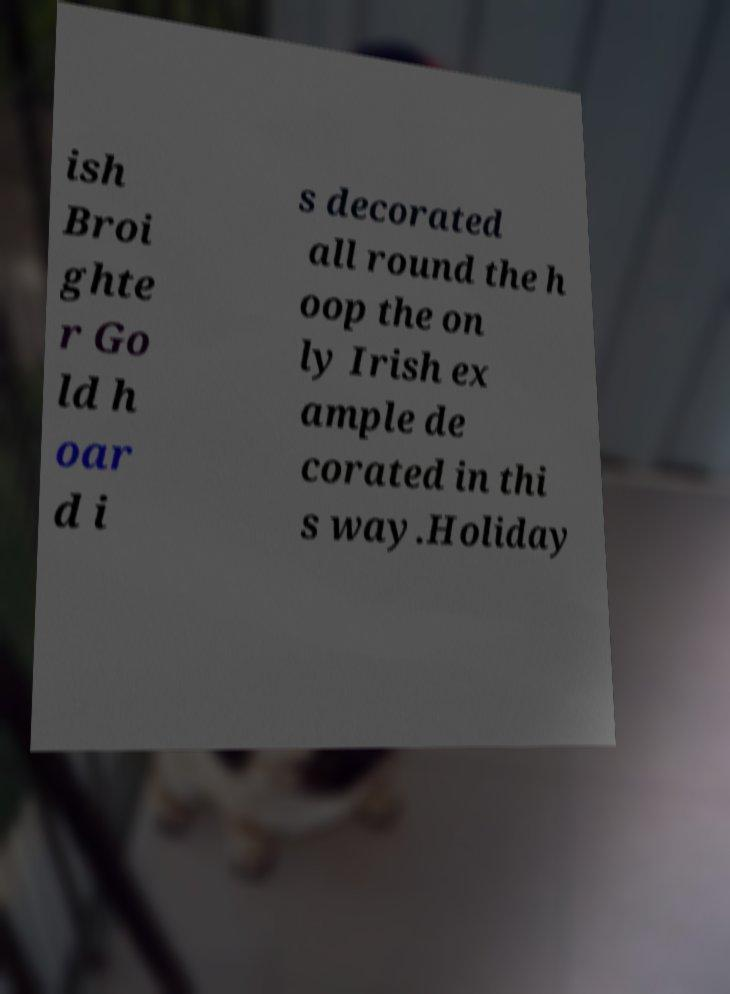Could you extract and type out the text from this image? ish Broi ghte r Go ld h oar d i s decorated all round the h oop the on ly Irish ex ample de corated in thi s way.Holiday 